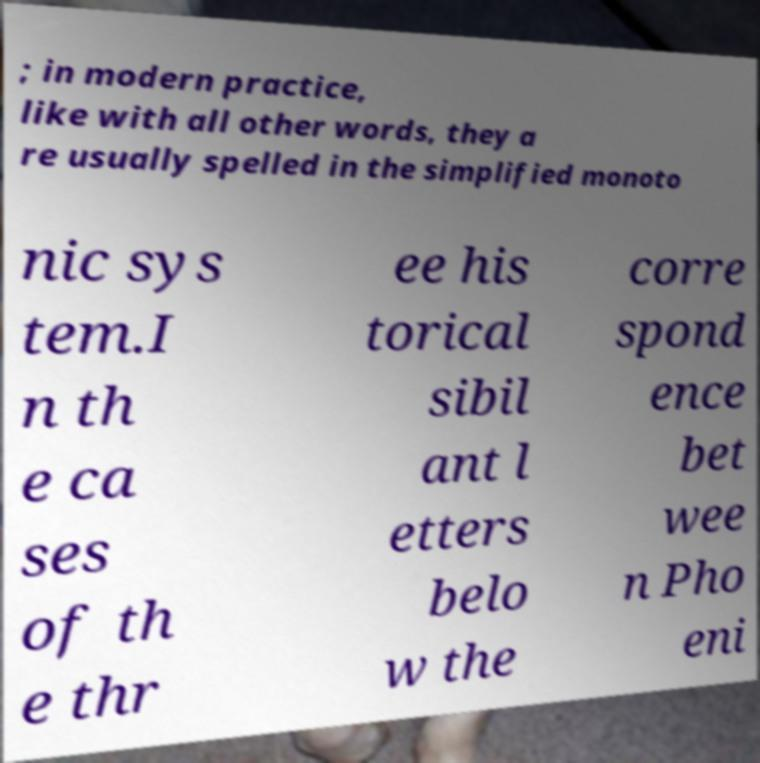Could you assist in decoding the text presented in this image and type it out clearly? ; in modern practice, like with all other words, they a re usually spelled in the simplified monoto nic sys tem.I n th e ca ses of th e thr ee his torical sibil ant l etters belo w the corre spond ence bet wee n Pho eni 